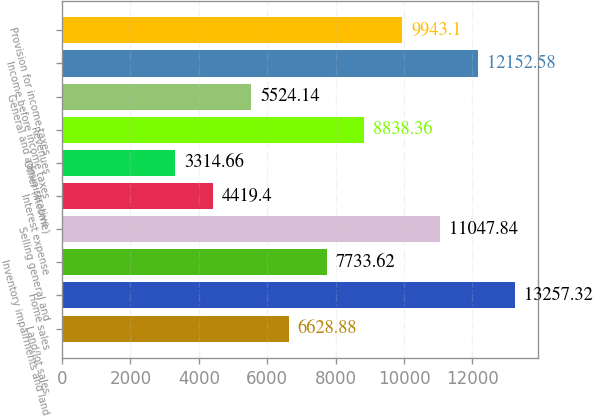Convert chart. <chart><loc_0><loc_0><loc_500><loc_500><bar_chart><fcel>Land/lot sales<fcel>Home sales<fcel>Inventory impairments and land<fcel>Selling general and<fcel>Interest expense<fcel>Other (income)<fcel>Revenues<fcel>General and administrative<fcel>Income before income taxes<fcel>Provision for income taxes<nl><fcel>6628.88<fcel>13257.3<fcel>7733.62<fcel>11047.8<fcel>4419.4<fcel>3314.66<fcel>8838.36<fcel>5524.14<fcel>12152.6<fcel>9943.1<nl></chart> 